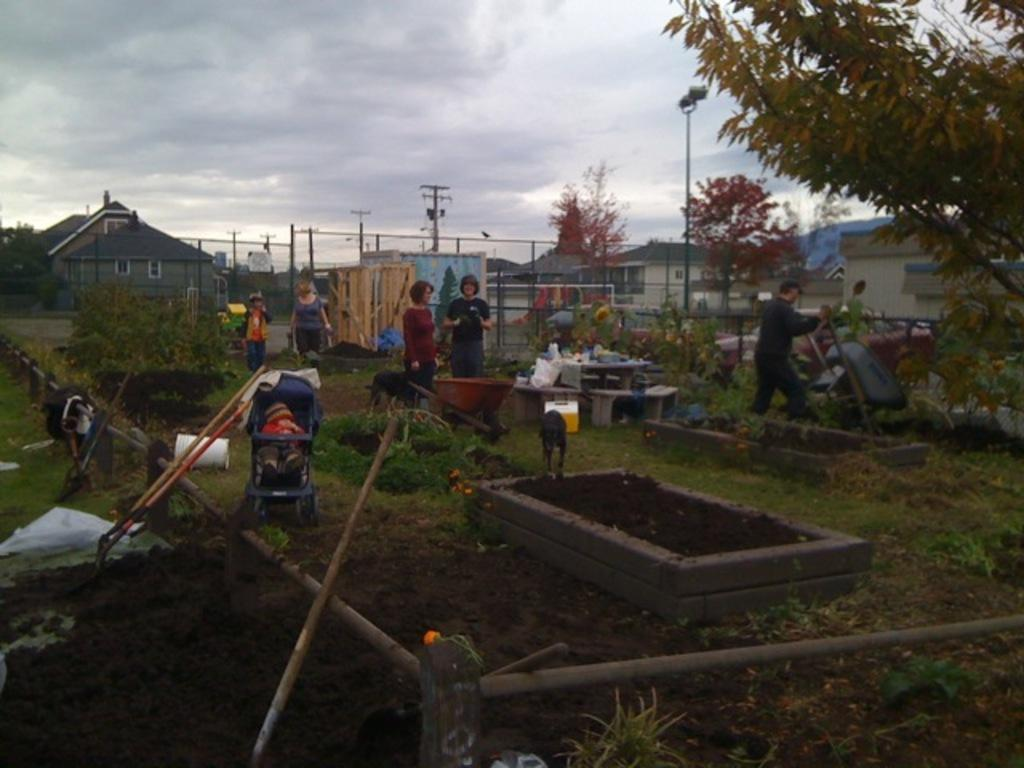What type of natural elements can be seen in the image? There are trees and plants in the image. Can you describe the people in the image? There are people in the image, but their specific actions or characteristics are not mentioned in the facts. What structures are present in the image? There are poles, houses, and benches in the image. What animals can be seen in the image? There are dogs in the image. What type of transportation is visible in the image? There is a stroller in the image, and a baby is inside it. What is the weather like in the image? The sky is visible in the background of the image, and it appears to be cloudy. What type of selection process is taking place in the image? There is no mention of a selection process in the image. How does the scale of the image compare to a real-life scene? The facts provided do not give any information about the scale of the image. What time of day is depicted in the image? The facts provided do not give any information about the time of day, but the absence of a reference to morning or any other time of day suggests that it is not a key aspect of the image. 